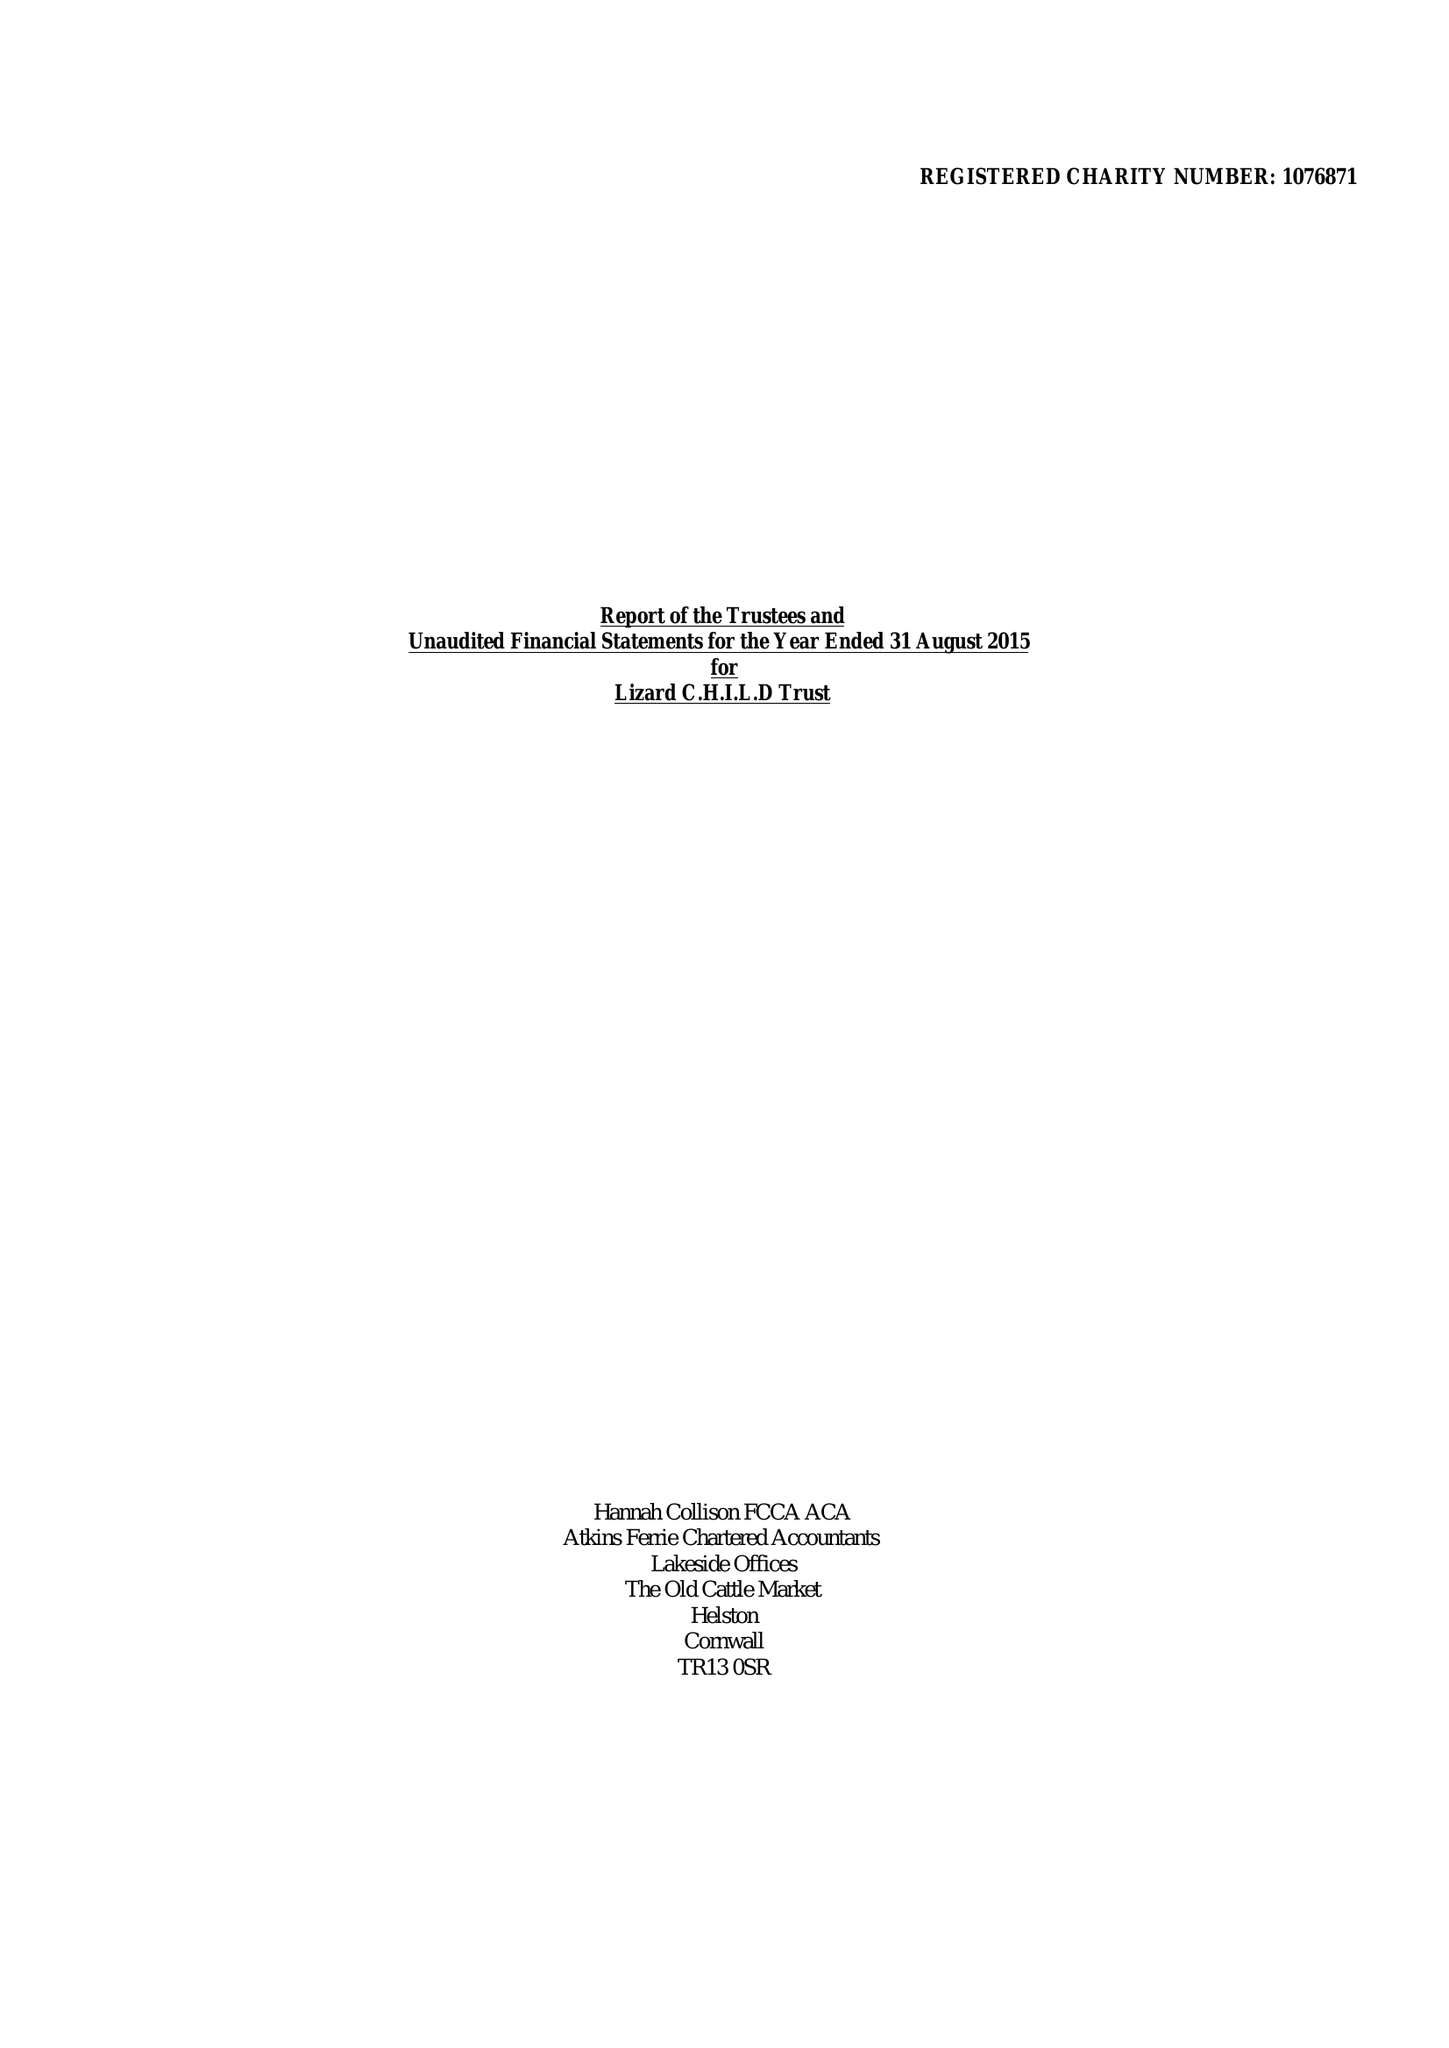What is the value for the address__street_line?
Answer the question using a single word or phrase. PENBERTHY ROAD 